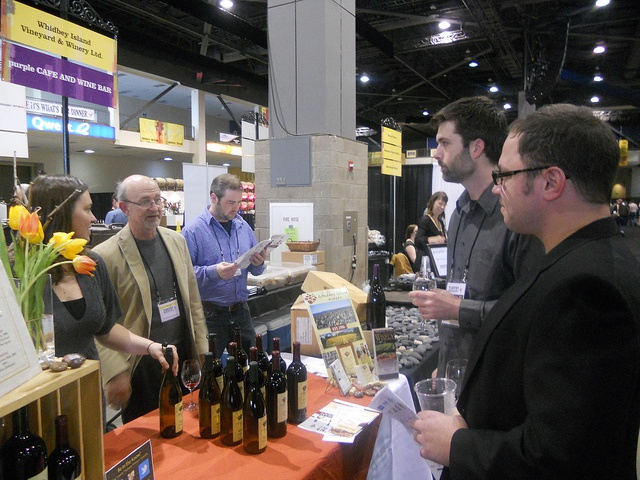Describe the objects in this image and their specific colors. I can see dining table in black, lightgray, darkgray, and maroon tones, people in black, gray, and lightpink tones, people in black, gray, and darkgray tones, people in black, gray, and darkgray tones, and people in black and gray tones in this image. 